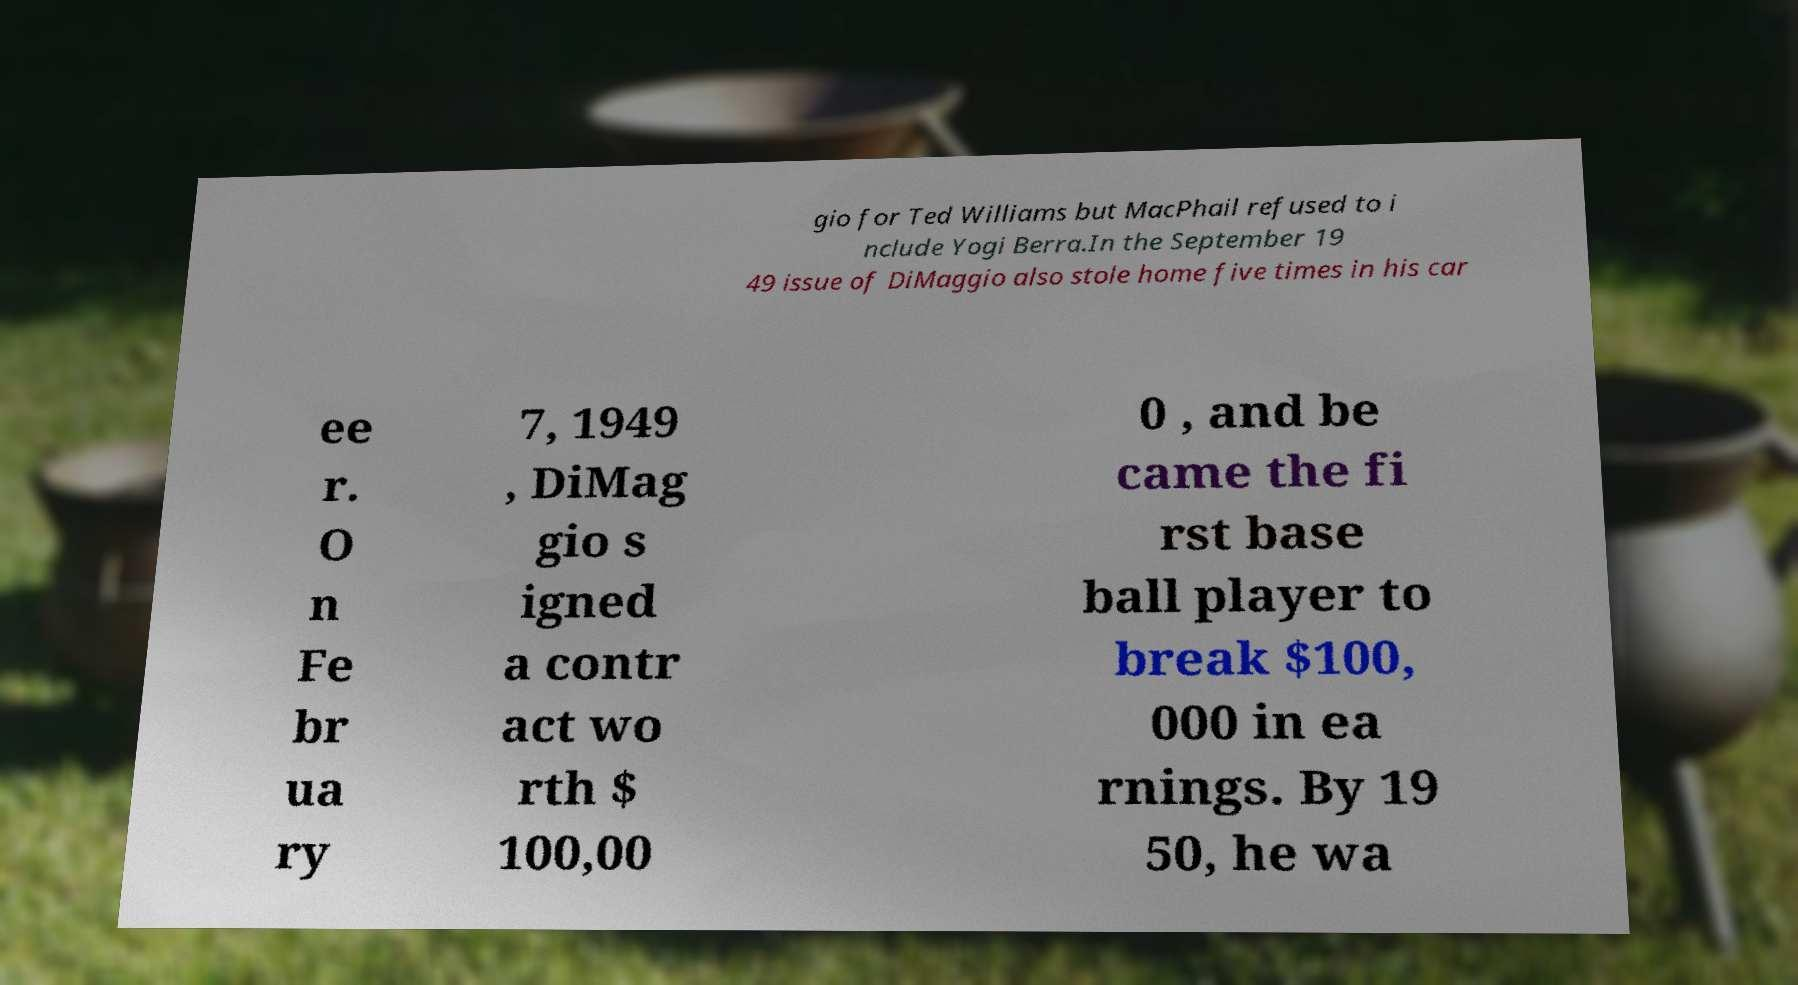What messages or text are displayed in this image? I need them in a readable, typed format. gio for Ted Williams but MacPhail refused to i nclude Yogi Berra.In the September 19 49 issue of DiMaggio also stole home five times in his car ee r. O n Fe br ua ry 7, 1949 , DiMag gio s igned a contr act wo rth $ 100,00 0 , and be came the fi rst base ball player to break $100, 000 in ea rnings. By 19 50, he wa 